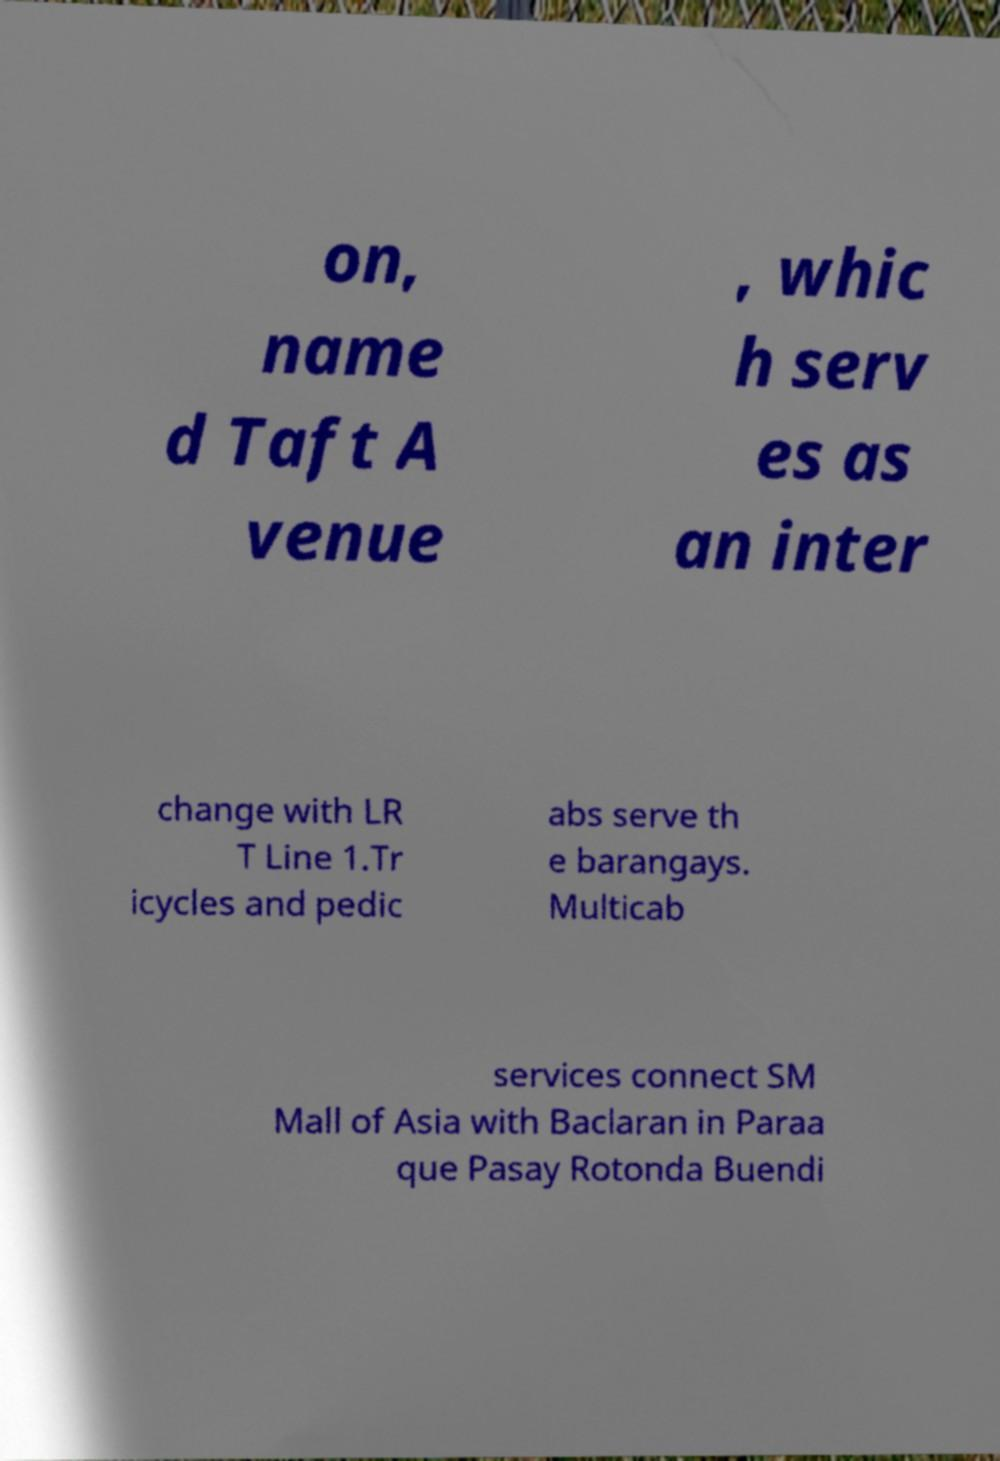There's text embedded in this image that I need extracted. Can you transcribe it verbatim? on, name d Taft A venue , whic h serv es as an inter change with LR T Line 1.Tr icycles and pedic abs serve th e barangays. Multicab services connect SM Mall of Asia with Baclaran in Paraa que Pasay Rotonda Buendi 